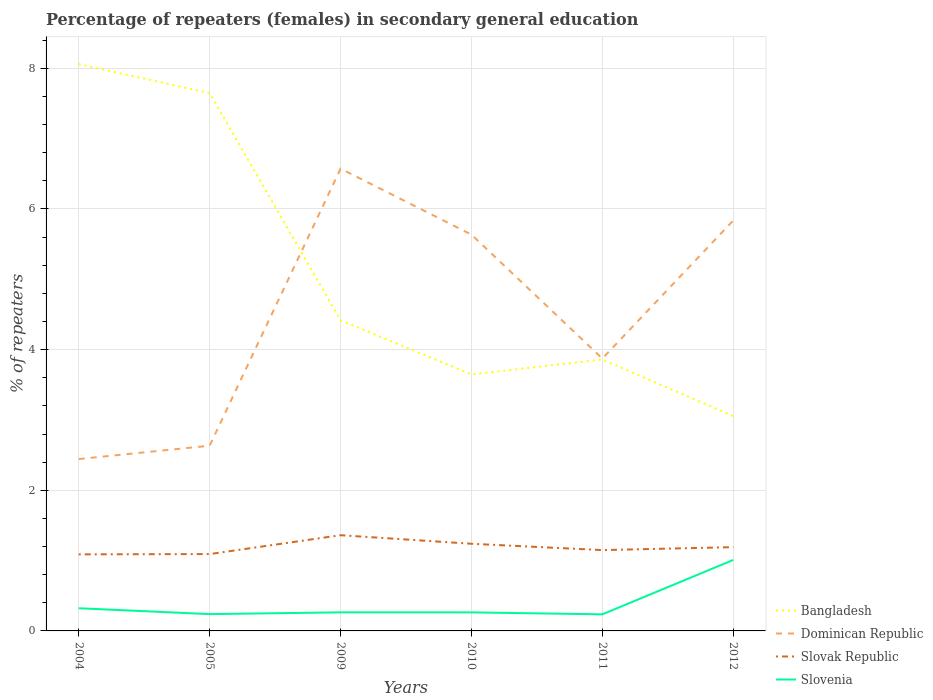How many different coloured lines are there?
Your answer should be compact. 4. Does the line corresponding to Slovenia intersect with the line corresponding to Bangladesh?
Offer a terse response. No. Is the number of lines equal to the number of legend labels?
Your answer should be compact. Yes. Across all years, what is the maximum percentage of female repeaters in Bangladesh?
Offer a terse response. 3.05. What is the total percentage of female repeaters in Slovak Republic in the graph?
Provide a succinct answer. 0.21. What is the difference between the highest and the second highest percentage of female repeaters in Bangladesh?
Offer a very short reply. 5.01. What is the difference between the highest and the lowest percentage of female repeaters in Slovenia?
Your response must be concise. 1. Is the percentage of female repeaters in Dominican Republic strictly greater than the percentage of female repeaters in Slovak Republic over the years?
Offer a terse response. No. How many years are there in the graph?
Offer a terse response. 6. Are the values on the major ticks of Y-axis written in scientific E-notation?
Ensure brevity in your answer.  No. Does the graph contain grids?
Your answer should be compact. Yes. Where does the legend appear in the graph?
Make the answer very short. Bottom right. How are the legend labels stacked?
Offer a very short reply. Vertical. What is the title of the graph?
Provide a short and direct response. Percentage of repeaters (females) in secondary general education. Does "Least developed countries" appear as one of the legend labels in the graph?
Your response must be concise. No. What is the label or title of the Y-axis?
Your answer should be very brief. % of repeaters. What is the % of repeaters in Bangladesh in 2004?
Your response must be concise. 8.06. What is the % of repeaters in Dominican Republic in 2004?
Provide a short and direct response. 2.44. What is the % of repeaters of Slovak Republic in 2004?
Provide a succinct answer. 1.09. What is the % of repeaters in Slovenia in 2004?
Your answer should be compact. 0.32. What is the % of repeaters of Bangladesh in 2005?
Keep it short and to the point. 7.65. What is the % of repeaters in Dominican Republic in 2005?
Keep it short and to the point. 2.63. What is the % of repeaters of Slovak Republic in 2005?
Keep it short and to the point. 1.09. What is the % of repeaters of Slovenia in 2005?
Give a very brief answer. 0.24. What is the % of repeaters in Bangladesh in 2009?
Your answer should be very brief. 4.42. What is the % of repeaters of Dominican Republic in 2009?
Make the answer very short. 6.57. What is the % of repeaters in Slovak Republic in 2009?
Your answer should be compact. 1.36. What is the % of repeaters in Slovenia in 2009?
Your response must be concise. 0.26. What is the % of repeaters of Bangladesh in 2010?
Make the answer very short. 3.65. What is the % of repeaters in Dominican Republic in 2010?
Ensure brevity in your answer.  5.64. What is the % of repeaters in Slovak Republic in 2010?
Offer a terse response. 1.24. What is the % of repeaters in Slovenia in 2010?
Your answer should be very brief. 0.26. What is the % of repeaters in Bangladesh in 2011?
Your response must be concise. 3.86. What is the % of repeaters of Dominican Republic in 2011?
Make the answer very short. 3.87. What is the % of repeaters of Slovak Republic in 2011?
Your response must be concise. 1.15. What is the % of repeaters in Slovenia in 2011?
Offer a terse response. 0.24. What is the % of repeaters in Bangladesh in 2012?
Provide a short and direct response. 3.05. What is the % of repeaters of Dominican Republic in 2012?
Offer a very short reply. 5.84. What is the % of repeaters of Slovak Republic in 2012?
Ensure brevity in your answer.  1.19. What is the % of repeaters of Slovenia in 2012?
Your answer should be compact. 1.01. Across all years, what is the maximum % of repeaters of Bangladesh?
Your answer should be very brief. 8.06. Across all years, what is the maximum % of repeaters of Dominican Republic?
Your answer should be compact. 6.57. Across all years, what is the maximum % of repeaters of Slovak Republic?
Keep it short and to the point. 1.36. Across all years, what is the maximum % of repeaters in Slovenia?
Provide a short and direct response. 1.01. Across all years, what is the minimum % of repeaters in Bangladesh?
Offer a terse response. 3.05. Across all years, what is the minimum % of repeaters of Dominican Republic?
Keep it short and to the point. 2.44. Across all years, what is the minimum % of repeaters in Slovak Republic?
Provide a succinct answer. 1.09. Across all years, what is the minimum % of repeaters of Slovenia?
Give a very brief answer. 0.24. What is the total % of repeaters of Bangladesh in the graph?
Keep it short and to the point. 30.69. What is the total % of repeaters of Dominican Republic in the graph?
Keep it short and to the point. 27. What is the total % of repeaters in Slovak Republic in the graph?
Your answer should be very brief. 7.12. What is the total % of repeaters of Slovenia in the graph?
Your answer should be compact. 2.33. What is the difference between the % of repeaters in Bangladesh in 2004 and that in 2005?
Offer a very short reply. 0.41. What is the difference between the % of repeaters of Dominican Republic in 2004 and that in 2005?
Your response must be concise. -0.19. What is the difference between the % of repeaters of Slovak Republic in 2004 and that in 2005?
Provide a short and direct response. -0. What is the difference between the % of repeaters in Slovenia in 2004 and that in 2005?
Give a very brief answer. 0.08. What is the difference between the % of repeaters of Bangladesh in 2004 and that in 2009?
Offer a very short reply. 3.64. What is the difference between the % of repeaters in Dominican Republic in 2004 and that in 2009?
Ensure brevity in your answer.  -4.13. What is the difference between the % of repeaters in Slovak Republic in 2004 and that in 2009?
Give a very brief answer. -0.27. What is the difference between the % of repeaters in Slovenia in 2004 and that in 2009?
Provide a succinct answer. 0.06. What is the difference between the % of repeaters in Bangladesh in 2004 and that in 2010?
Your answer should be compact. 4.41. What is the difference between the % of repeaters of Dominican Republic in 2004 and that in 2010?
Provide a short and direct response. -3.19. What is the difference between the % of repeaters of Slovak Republic in 2004 and that in 2010?
Give a very brief answer. -0.15. What is the difference between the % of repeaters in Slovenia in 2004 and that in 2010?
Keep it short and to the point. 0.06. What is the difference between the % of repeaters in Bangladesh in 2004 and that in 2011?
Your response must be concise. 4.2. What is the difference between the % of repeaters of Dominican Republic in 2004 and that in 2011?
Make the answer very short. -1.43. What is the difference between the % of repeaters in Slovak Republic in 2004 and that in 2011?
Your response must be concise. -0.06. What is the difference between the % of repeaters in Slovenia in 2004 and that in 2011?
Ensure brevity in your answer.  0.09. What is the difference between the % of repeaters in Bangladesh in 2004 and that in 2012?
Make the answer very short. 5.01. What is the difference between the % of repeaters in Dominican Republic in 2004 and that in 2012?
Provide a short and direct response. -3.39. What is the difference between the % of repeaters in Slovak Republic in 2004 and that in 2012?
Ensure brevity in your answer.  -0.1. What is the difference between the % of repeaters of Slovenia in 2004 and that in 2012?
Make the answer very short. -0.69. What is the difference between the % of repeaters of Bangladesh in 2005 and that in 2009?
Provide a short and direct response. 3.23. What is the difference between the % of repeaters in Dominican Republic in 2005 and that in 2009?
Your response must be concise. -3.94. What is the difference between the % of repeaters in Slovak Republic in 2005 and that in 2009?
Give a very brief answer. -0.27. What is the difference between the % of repeaters of Slovenia in 2005 and that in 2009?
Ensure brevity in your answer.  -0.03. What is the difference between the % of repeaters in Bangladesh in 2005 and that in 2010?
Give a very brief answer. 4. What is the difference between the % of repeaters in Dominican Republic in 2005 and that in 2010?
Offer a terse response. -3. What is the difference between the % of repeaters in Slovak Republic in 2005 and that in 2010?
Offer a very short reply. -0.15. What is the difference between the % of repeaters in Slovenia in 2005 and that in 2010?
Offer a terse response. -0.02. What is the difference between the % of repeaters in Bangladesh in 2005 and that in 2011?
Give a very brief answer. 3.79. What is the difference between the % of repeaters in Dominican Republic in 2005 and that in 2011?
Make the answer very short. -1.24. What is the difference between the % of repeaters in Slovak Republic in 2005 and that in 2011?
Offer a terse response. -0.06. What is the difference between the % of repeaters of Slovenia in 2005 and that in 2011?
Offer a very short reply. 0. What is the difference between the % of repeaters in Bangladesh in 2005 and that in 2012?
Give a very brief answer. 4.59. What is the difference between the % of repeaters of Dominican Republic in 2005 and that in 2012?
Offer a terse response. -3.2. What is the difference between the % of repeaters of Slovak Republic in 2005 and that in 2012?
Provide a succinct answer. -0.1. What is the difference between the % of repeaters of Slovenia in 2005 and that in 2012?
Give a very brief answer. -0.77. What is the difference between the % of repeaters of Bangladesh in 2009 and that in 2010?
Your response must be concise. 0.77. What is the difference between the % of repeaters in Dominican Republic in 2009 and that in 2010?
Provide a short and direct response. 0.94. What is the difference between the % of repeaters in Slovak Republic in 2009 and that in 2010?
Your answer should be compact. 0.12. What is the difference between the % of repeaters of Slovenia in 2009 and that in 2010?
Offer a terse response. 0. What is the difference between the % of repeaters in Bangladesh in 2009 and that in 2011?
Your answer should be compact. 0.56. What is the difference between the % of repeaters in Dominican Republic in 2009 and that in 2011?
Provide a succinct answer. 2.7. What is the difference between the % of repeaters in Slovak Republic in 2009 and that in 2011?
Keep it short and to the point. 0.21. What is the difference between the % of repeaters of Slovenia in 2009 and that in 2011?
Ensure brevity in your answer.  0.03. What is the difference between the % of repeaters of Bangladesh in 2009 and that in 2012?
Your answer should be very brief. 1.36. What is the difference between the % of repeaters of Dominican Republic in 2009 and that in 2012?
Keep it short and to the point. 0.74. What is the difference between the % of repeaters of Slovak Republic in 2009 and that in 2012?
Your answer should be compact. 0.17. What is the difference between the % of repeaters of Slovenia in 2009 and that in 2012?
Offer a very short reply. -0.74. What is the difference between the % of repeaters in Bangladesh in 2010 and that in 2011?
Ensure brevity in your answer.  -0.21. What is the difference between the % of repeaters of Dominican Republic in 2010 and that in 2011?
Provide a succinct answer. 1.76. What is the difference between the % of repeaters in Slovak Republic in 2010 and that in 2011?
Your answer should be compact. 0.09. What is the difference between the % of repeaters in Slovenia in 2010 and that in 2011?
Provide a succinct answer. 0.03. What is the difference between the % of repeaters of Bangladesh in 2010 and that in 2012?
Offer a terse response. 0.59. What is the difference between the % of repeaters of Dominican Republic in 2010 and that in 2012?
Your answer should be compact. -0.2. What is the difference between the % of repeaters of Slovak Republic in 2010 and that in 2012?
Provide a succinct answer. 0.05. What is the difference between the % of repeaters in Slovenia in 2010 and that in 2012?
Ensure brevity in your answer.  -0.75. What is the difference between the % of repeaters of Bangladesh in 2011 and that in 2012?
Make the answer very short. 0.81. What is the difference between the % of repeaters of Dominican Republic in 2011 and that in 2012?
Provide a short and direct response. -1.96. What is the difference between the % of repeaters in Slovak Republic in 2011 and that in 2012?
Provide a short and direct response. -0.04. What is the difference between the % of repeaters of Slovenia in 2011 and that in 2012?
Your answer should be compact. -0.77. What is the difference between the % of repeaters in Bangladesh in 2004 and the % of repeaters in Dominican Republic in 2005?
Provide a succinct answer. 5.43. What is the difference between the % of repeaters of Bangladesh in 2004 and the % of repeaters of Slovak Republic in 2005?
Your answer should be very brief. 6.97. What is the difference between the % of repeaters of Bangladesh in 2004 and the % of repeaters of Slovenia in 2005?
Your answer should be compact. 7.82. What is the difference between the % of repeaters of Dominican Republic in 2004 and the % of repeaters of Slovak Republic in 2005?
Make the answer very short. 1.35. What is the difference between the % of repeaters in Dominican Republic in 2004 and the % of repeaters in Slovenia in 2005?
Your answer should be compact. 2.2. What is the difference between the % of repeaters in Slovak Republic in 2004 and the % of repeaters in Slovenia in 2005?
Ensure brevity in your answer.  0.85. What is the difference between the % of repeaters of Bangladesh in 2004 and the % of repeaters of Dominican Republic in 2009?
Keep it short and to the point. 1.49. What is the difference between the % of repeaters in Bangladesh in 2004 and the % of repeaters in Slovak Republic in 2009?
Your answer should be compact. 6.7. What is the difference between the % of repeaters of Bangladesh in 2004 and the % of repeaters of Slovenia in 2009?
Your answer should be very brief. 7.8. What is the difference between the % of repeaters of Dominican Republic in 2004 and the % of repeaters of Slovak Republic in 2009?
Ensure brevity in your answer.  1.08. What is the difference between the % of repeaters in Dominican Republic in 2004 and the % of repeaters in Slovenia in 2009?
Offer a very short reply. 2.18. What is the difference between the % of repeaters of Slovak Republic in 2004 and the % of repeaters of Slovenia in 2009?
Make the answer very short. 0.82. What is the difference between the % of repeaters of Bangladesh in 2004 and the % of repeaters of Dominican Republic in 2010?
Provide a short and direct response. 2.42. What is the difference between the % of repeaters in Bangladesh in 2004 and the % of repeaters in Slovak Republic in 2010?
Offer a terse response. 6.82. What is the difference between the % of repeaters of Bangladesh in 2004 and the % of repeaters of Slovenia in 2010?
Ensure brevity in your answer.  7.8. What is the difference between the % of repeaters of Dominican Republic in 2004 and the % of repeaters of Slovak Republic in 2010?
Provide a succinct answer. 1.2. What is the difference between the % of repeaters of Dominican Republic in 2004 and the % of repeaters of Slovenia in 2010?
Ensure brevity in your answer.  2.18. What is the difference between the % of repeaters of Slovak Republic in 2004 and the % of repeaters of Slovenia in 2010?
Your answer should be very brief. 0.82. What is the difference between the % of repeaters in Bangladesh in 2004 and the % of repeaters in Dominican Republic in 2011?
Offer a terse response. 4.19. What is the difference between the % of repeaters in Bangladesh in 2004 and the % of repeaters in Slovak Republic in 2011?
Provide a succinct answer. 6.91. What is the difference between the % of repeaters of Bangladesh in 2004 and the % of repeaters of Slovenia in 2011?
Give a very brief answer. 7.82. What is the difference between the % of repeaters of Dominican Republic in 2004 and the % of repeaters of Slovak Republic in 2011?
Make the answer very short. 1.29. What is the difference between the % of repeaters in Dominican Republic in 2004 and the % of repeaters in Slovenia in 2011?
Offer a terse response. 2.21. What is the difference between the % of repeaters in Slovak Republic in 2004 and the % of repeaters in Slovenia in 2011?
Offer a very short reply. 0.85. What is the difference between the % of repeaters in Bangladesh in 2004 and the % of repeaters in Dominican Republic in 2012?
Ensure brevity in your answer.  2.22. What is the difference between the % of repeaters of Bangladesh in 2004 and the % of repeaters of Slovak Republic in 2012?
Your response must be concise. 6.87. What is the difference between the % of repeaters in Bangladesh in 2004 and the % of repeaters in Slovenia in 2012?
Keep it short and to the point. 7.05. What is the difference between the % of repeaters in Dominican Republic in 2004 and the % of repeaters in Slovak Republic in 2012?
Provide a short and direct response. 1.25. What is the difference between the % of repeaters in Dominican Republic in 2004 and the % of repeaters in Slovenia in 2012?
Offer a terse response. 1.43. What is the difference between the % of repeaters in Slovak Republic in 2004 and the % of repeaters in Slovenia in 2012?
Ensure brevity in your answer.  0.08. What is the difference between the % of repeaters in Bangladesh in 2005 and the % of repeaters in Dominican Republic in 2009?
Offer a very short reply. 1.07. What is the difference between the % of repeaters of Bangladesh in 2005 and the % of repeaters of Slovak Republic in 2009?
Offer a terse response. 6.29. What is the difference between the % of repeaters in Bangladesh in 2005 and the % of repeaters in Slovenia in 2009?
Your answer should be compact. 7.38. What is the difference between the % of repeaters in Dominican Republic in 2005 and the % of repeaters in Slovak Republic in 2009?
Offer a terse response. 1.27. What is the difference between the % of repeaters of Dominican Republic in 2005 and the % of repeaters of Slovenia in 2009?
Offer a terse response. 2.37. What is the difference between the % of repeaters in Slovak Republic in 2005 and the % of repeaters in Slovenia in 2009?
Provide a succinct answer. 0.83. What is the difference between the % of repeaters of Bangladesh in 2005 and the % of repeaters of Dominican Republic in 2010?
Provide a succinct answer. 2.01. What is the difference between the % of repeaters in Bangladesh in 2005 and the % of repeaters in Slovak Republic in 2010?
Provide a short and direct response. 6.41. What is the difference between the % of repeaters of Bangladesh in 2005 and the % of repeaters of Slovenia in 2010?
Your answer should be compact. 7.38. What is the difference between the % of repeaters of Dominican Republic in 2005 and the % of repeaters of Slovak Republic in 2010?
Offer a very short reply. 1.39. What is the difference between the % of repeaters in Dominican Republic in 2005 and the % of repeaters in Slovenia in 2010?
Your answer should be very brief. 2.37. What is the difference between the % of repeaters of Slovak Republic in 2005 and the % of repeaters of Slovenia in 2010?
Your response must be concise. 0.83. What is the difference between the % of repeaters of Bangladesh in 2005 and the % of repeaters of Dominican Republic in 2011?
Offer a terse response. 3.77. What is the difference between the % of repeaters in Bangladesh in 2005 and the % of repeaters in Slovak Republic in 2011?
Offer a very short reply. 6.5. What is the difference between the % of repeaters of Bangladesh in 2005 and the % of repeaters of Slovenia in 2011?
Provide a succinct answer. 7.41. What is the difference between the % of repeaters in Dominican Republic in 2005 and the % of repeaters in Slovak Republic in 2011?
Provide a succinct answer. 1.48. What is the difference between the % of repeaters in Dominican Republic in 2005 and the % of repeaters in Slovenia in 2011?
Offer a terse response. 2.4. What is the difference between the % of repeaters in Slovak Republic in 2005 and the % of repeaters in Slovenia in 2011?
Your answer should be compact. 0.86. What is the difference between the % of repeaters of Bangladesh in 2005 and the % of repeaters of Dominican Republic in 2012?
Your response must be concise. 1.81. What is the difference between the % of repeaters in Bangladesh in 2005 and the % of repeaters in Slovak Republic in 2012?
Ensure brevity in your answer.  6.46. What is the difference between the % of repeaters of Bangladesh in 2005 and the % of repeaters of Slovenia in 2012?
Give a very brief answer. 6.64. What is the difference between the % of repeaters in Dominican Republic in 2005 and the % of repeaters in Slovak Republic in 2012?
Keep it short and to the point. 1.44. What is the difference between the % of repeaters of Dominican Republic in 2005 and the % of repeaters of Slovenia in 2012?
Your answer should be very brief. 1.62. What is the difference between the % of repeaters in Slovak Republic in 2005 and the % of repeaters in Slovenia in 2012?
Offer a very short reply. 0.08. What is the difference between the % of repeaters of Bangladesh in 2009 and the % of repeaters of Dominican Republic in 2010?
Keep it short and to the point. -1.22. What is the difference between the % of repeaters in Bangladesh in 2009 and the % of repeaters in Slovak Republic in 2010?
Keep it short and to the point. 3.18. What is the difference between the % of repeaters of Bangladesh in 2009 and the % of repeaters of Slovenia in 2010?
Make the answer very short. 4.15. What is the difference between the % of repeaters in Dominican Republic in 2009 and the % of repeaters in Slovak Republic in 2010?
Offer a terse response. 5.33. What is the difference between the % of repeaters in Dominican Republic in 2009 and the % of repeaters in Slovenia in 2010?
Give a very brief answer. 6.31. What is the difference between the % of repeaters of Slovak Republic in 2009 and the % of repeaters of Slovenia in 2010?
Provide a short and direct response. 1.1. What is the difference between the % of repeaters of Bangladesh in 2009 and the % of repeaters of Dominican Republic in 2011?
Give a very brief answer. 0.54. What is the difference between the % of repeaters in Bangladesh in 2009 and the % of repeaters in Slovak Republic in 2011?
Offer a very short reply. 3.27. What is the difference between the % of repeaters in Bangladesh in 2009 and the % of repeaters in Slovenia in 2011?
Provide a short and direct response. 4.18. What is the difference between the % of repeaters of Dominican Republic in 2009 and the % of repeaters of Slovak Republic in 2011?
Provide a succinct answer. 5.42. What is the difference between the % of repeaters in Dominican Republic in 2009 and the % of repeaters in Slovenia in 2011?
Offer a very short reply. 6.34. What is the difference between the % of repeaters in Slovak Republic in 2009 and the % of repeaters in Slovenia in 2011?
Offer a terse response. 1.12. What is the difference between the % of repeaters in Bangladesh in 2009 and the % of repeaters in Dominican Republic in 2012?
Provide a short and direct response. -1.42. What is the difference between the % of repeaters in Bangladesh in 2009 and the % of repeaters in Slovak Republic in 2012?
Ensure brevity in your answer.  3.23. What is the difference between the % of repeaters in Bangladesh in 2009 and the % of repeaters in Slovenia in 2012?
Ensure brevity in your answer.  3.41. What is the difference between the % of repeaters in Dominican Republic in 2009 and the % of repeaters in Slovak Republic in 2012?
Offer a very short reply. 5.38. What is the difference between the % of repeaters in Dominican Republic in 2009 and the % of repeaters in Slovenia in 2012?
Provide a short and direct response. 5.56. What is the difference between the % of repeaters of Slovak Republic in 2009 and the % of repeaters of Slovenia in 2012?
Your response must be concise. 0.35. What is the difference between the % of repeaters in Bangladesh in 2010 and the % of repeaters in Dominican Republic in 2011?
Your answer should be very brief. -0.23. What is the difference between the % of repeaters in Bangladesh in 2010 and the % of repeaters in Slovak Republic in 2011?
Ensure brevity in your answer.  2.5. What is the difference between the % of repeaters of Bangladesh in 2010 and the % of repeaters of Slovenia in 2011?
Offer a very short reply. 3.41. What is the difference between the % of repeaters in Dominican Republic in 2010 and the % of repeaters in Slovak Republic in 2011?
Keep it short and to the point. 4.49. What is the difference between the % of repeaters in Dominican Republic in 2010 and the % of repeaters in Slovenia in 2011?
Your answer should be compact. 5.4. What is the difference between the % of repeaters in Slovak Republic in 2010 and the % of repeaters in Slovenia in 2011?
Make the answer very short. 1. What is the difference between the % of repeaters in Bangladesh in 2010 and the % of repeaters in Dominican Republic in 2012?
Provide a succinct answer. -2.19. What is the difference between the % of repeaters in Bangladesh in 2010 and the % of repeaters in Slovak Republic in 2012?
Provide a short and direct response. 2.46. What is the difference between the % of repeaters in Bangladesh in 2010 and the % of repeaters in Slovenia in 2012?
Your response must be concise. 2.64. What is the difference between the % of repeaters in Dominican Republic in 2010 and the % of repeaters in Slovak Republic in 2012?
Provide a succinct answer. 4.44. What is the difference between the % of repeaters of Dominican Republic in 2010 and the % of repeaters of Slovenia in 2012?
Provide a short and direct response. 4.63. What is the difference between the % of repeaters of Slovak Republic in 2010 and the % of repeaters of Slovenia in 2012?
Provide a short and direct response. 0.23. What is the difference between the % of repeaters in Bangladesh in 2011 and the % of repeaters in Dominican Republic in 2012?
Offer a very short reply. -1.98. What is the difference between the % of repeaters in Bangladesh in 2011 and the % of repeaters in Slovak Republic in 2012?
Your answer should be very brief. 2.67. What is the difference between the % of repeaters in Bangladesh in 2011 and the % of repeaters in Slovenia in 2012?
Your answer should be very brief. 2.85. What is the difference between the % of repeaters in Dominican Republic in 2011 and the % of repeaters in Slovak Republic in 2012?
Keep it short and to the point. 2.68. What is the difference between the % of repeaters of Dominican Republic in 2011 and the % of repeaters of Slovenia in 2012?
Your answer should be very brief. 2.86. What is the difference between the % of repeaters in Slovak Republic in 2011 and the % of repeaters in Slovenia in 2012?
Your answer should be compact. 0.14. What is the average % of repeaters of Bangladesh per year?
Ensure brevity in your answer.  5.11. What is the average % of repeaters in Dominican Republic per year?
Your answer should be compact. 4.5. What is the average % of repeaters in Slovak Republic per year?
Keep it short and to the point. 1.19. What is the average % of repeaters of Slovenia per year?
Provide a short and direct response. 0.39. In the year 2004, what is the difference between the % of repeaters of Bangladesh and % of repeaters of Dominican Republic?
Offer a very short reply. 5.62. In the year 2004, what is the difference between the % of repeaters in Bangladesh and % of repeaters in Slovak Republic?
Make the answer very short. 6.97. In the year 2004, what is the difference between the % of repeaters in Bangladesh and % of repeaters in Slovenia?
Your response must be concise. 7.74. In the year 2004, what is the difference between the % of repeaters of Dominican Republic and % of repeaters of Slovak Republic?
Give a very brief answer. 1.36. In the year 2004, what is the difference between the % of repeaters of Dominican Republic and % of repeaters of Slovenia?
Ensure brevity in your answer.  2.12. In the year 2004, what is the difference between the % of repeaters in Slovak Republic and % of repeaters in Slovenia?
Your answer should be very brief. 0.77. In the year 2005, what is the difference between the % of repeaters of Bangladesh and % of repeaters of Dominican Republic?
Give a very brief answer. 5.01. In the year 2005, what is the difference between the % of repeaters in Bangladesh and % of repeaters in Slovak Republic?
Keep it short and to the point. 6.55. In the year 2005, what is the difference between the % of repeaters in Bangladesh and % of repeaters in Slovenia?
Your response must be concise. 7.41. In the year 2005, what is the difference between the % of repeaters of Dominican Republic and % of repeaters of Slovak Republic?
Make the answer very short. 1.54. In the year 2005, what is the difference between the % of repeaters of Dominican Republic and % of repeaters of Slovenia?
Provide a succinct answer. 2.39. In the year 2005, what is the difference between the % of repeaters in Slovak Republic and % of repeaters in Slovenia?
Keep it short and to the point. 0.85. In the year 2009, what is the difference between the % of repeaters of Bangladesh and % of repeaters of Dominican Republic?
Your response must be concise. -2.16. In the year 2009, what is the difference between the % of repeaters of Bangladesh and % of repeaters of Slovak Republic?
Provide a short and direct response. 3.06. In the year 2009, what is the difference between the % of repeaters of Bangladesh and % of repeaters of Slovenia?
Provide a short and direct response. 4.15. In the year 2009, what is the difference between the % of repeaters of Dominican Republic and % of repeaters of Slovak Republic?
Your response must be concise. 5.21. In the year 2009, what is the difference between the % of repeaters of Dominican Republic and % of repeaters of Slovenia?
Your response must be concise. 6.31. In the year 2009, what is the difference between the % of repeaters in Slovak Republic and % of repeaters in Slovenia?
Keep it short and to the point. 1.1. In the year 2010, what is the difference between the % of repeaters in Bangladesh and % of repeaters in Dominican Republic?
Make the answer very short. -1.99. In the year 2010, what is the difference between the % of repeaters of Bangladesh and % of repeaters of Slovak Republic?
Your answer should be compact. 2.41. In the year 2010, what is the difference between the % of repeaters of Bangladesh and % of repeaters of Slovenia?
Provide a succinct answer. 3.38. In the year 2010, what is the difference between the % of repeaters in Dominican Republic and % of repeaters in Slovak Republic?
Give a very brief answer. 4.4. In the year 2010, what is the difference between the % of repeaters of Dominican Republic and % of repeaters of Slovenia?
Your answer should be very brief. 5.37. In the year 2010, what is the difference between the % of repeaters in Slovak Republic and % of repeaters in Slovenia?
Offer a very short reply. 0.98. In the year 2011, what is the difference between the % of repeaters in Bangladesh and % of repeaters in Dominican Republic?
Provide a succinct answer. -0.01. In the year 2011, what is the difference between the % of repeaters in Bangladesh and % of repeaters in Slovak Republic?
Your answer should be compact. 2.71. In the year 2011, what is the difference between the % of repeaters in Bangladesh and % of repeaters in Slovenia?
Ensure brevity in your answer.  3.62. In the year 2011, what is the difference between the % of repeaters in Dominican Republic and % of repeaters in Slovak Republic?
Make the answer very short. 2.72. In the year 2011, what is the difference between the % of repeaters of Dominican Republic and % of repeaters of Slovenia?
Your response must be concise. 3.64. In the year 2011, what is the difference between the % of repeaters in Slovak Republic and % of repeaters in Slovenia?
Your answer should be very brief. 0.91. In the year 2012, what is the difference between the % of repeaters in Bangladesh and % of repeaters in Dominican Republic?
Your answer should be very brief. -2.78. In the year 2012, what is the difference between the % of repeaters in Bangladesh and % of repeaters in Slovak Republic?
Ensure brevity in your answer.  1.86. In the year 2012, what is the difference between the % of repeaters in Bangladesh and % of repeaters in Slovenia?
Your answer should be very brief. 2.04. In the year 2012, what is the difference between the % of repeaters in Dominican Republic and % of repeaters in Slovak Republic?
Your response must be concise. 4.64. In the year 2012, what is the difference between the % of repeaters in Dominican Republic and % of repeaters in Slovenia?
Your answer should be compact. 4.83. In the year 2012, what is the difference between the % of repeaters of Slovak Republic and % of repeaters of Slovenia?
Your response must be concise. 0.18. What is the ratio of the % of repeaters in Bangladesh in 2004 to that in 2005?
Provide a short and direct response. 1.05. What is the ratio of the % of repeaters in Dominican Republic in 2004 to that in 2005?
Offer a terse response. 0.93. What is the ratio of the % of repeaters in Slovenia in 2004 to that in 2005?
Your answer should be compact. 1.35. What is the ratio of the % of repeaters of Bangladesh in 2004 to that in 2009?
Make the answer very short. 1.82. What is the ratio of the % of repeaters of Dominican Republic in 2004 to that in 2009?
Offer a very short reply. 0.37. What is the ratio of the % of repeaters in Slovenia in 2004 to that in 2009?
Make the answer very short. 1.22. What is the ratio of the % of repeaters of Bangladesh in 2004 to that in 2010?
Your answer should be very brief. 2.21. What is the ratio of the % of repeaters of Dominican Republic in 2004 to that in 2010?
Your answer should be very brief. 0.43. What is the ratio of the % of repeaters in Slovak Republic in 2004 to that in 2010?
Offer a terse response. 0.88. What is the ratio of the % of repeaters of Slovenia in 2004 to that in 2010?
Give a very brief answer. 1.22. What is the ratio of the % of repeaters of Bangladesh in 2004 to that in 2011?
Make the answer very short. 2.09. What is the ratio of the % of repeaters in Dominican Republic in 2004 to that in 2011?
Provide a short and direct response. 0.63. What is the ratio of the % of repeaters in Slovak Republic in 2004 to that in 2011?
Ensure brevity in your answer.  0.95. What is the ratio of the % of repeaters of Slovenia in 2004 to that in 2011?
Ensure brevity in your answer.  1.37. What is the ratio of the % of repeaters of Bangladesh in 2004 to that in 2012?
Ensure brevity in your answer.  2.64. What is the ratio of the % of repeaters of Dominican Republic in 2004 to that in 2012?
Provide a succinct answer. 0.42. What is the ratio of the % of repeaters of Slovak Republic in 2004 to that in 2012?
Provide a short and direct response. 0.91. What is the ratio of the % of repeaters in Slovenia in 2004 to that in 2012?
Your answer should be very brief. 0.32. What is the ratio of the % of repeaters in Bangladesh in 2005 to that in 2009?
Keep it short and to the point. 1.73. What is the ratio of the % of repeaters of Dominican Republic in 2005 to that in 2009?
Your response must be concise. 0.4. What is the ratio of the % of repeaters in Slovak Republic in 2005 to that in 2009?
Provide a short and direct response. 0.8. What is the ratio of the % of repeaters of Slovenia in 2005 to that in 2009?
Offer a very short reply. 0.9. What is the ratio of the % of repeaters in Bangladesh in 2005 to that in 2010?
Make the answer very short. 2.1. What is the ratio of the % of repeaters in Dominican Republic in 2005 to that in 2010?
Your response must be concise. 0.47. What is the ratio of the % of repeaters in Slovak Republic in 2005 to that in 2010?
Your answer should be very brief. 0.88. What is the ratio of the % of repeaters in Slovenia in 2005 to that in 2010?
Provide a short and direct response. 0.91. What is the ratio of the % of repeaters of Bangladesh in 2005 to that in 2011?
Offer a terse response. 1.98. What is the ratio of the % of repeaters of Dominican Republic in 2005 to that in 2011?
Ensure brevity in your answer.  0.68. What is the ratio of the % of repeaters in Slovak Republic in 2005 to that in 2011?
Offer a terse response. 0.95. What is the ratio of the % of repeaters of Slovenia in 2005 to that in 2011?
Your response must be concise. 1.01. What is the ratio of the % of repeaters of Bangladesh in 2005 to that in 2012?
Offer a terse response. 2.5. What is the ratio of the % of repeaters of Dominican Republic in 2005 to that in 2012?
Keep it short and to the point. 0.45. What is the ratio of the % of repeaters of Slovak Republic in 2005 to that in 2012?
Offer a very short reply. 0.92. What is the ratio of the % of repeaters in Slovenia in 2005 to that in 2012?
Provide a succinct answer. 0.24. What is the ratio of the % of repeaters of Bangladesh in 2009 to that in 2010?
Your answer should be very brief. 1.21. What is the ratio of the % of repeaters of Dominican Republic in 2009 to that in 2010?
Give a very brief answer. 1.17. What is the ratio of the % of repeaters of Slovak Republic in 2009 to that in 2010?
Ensure brevity in your answer.  1.1. What is the ratio of the % of repeaters of Slovenia in 2009 to that in 2010?
Offer a terse response. 1. What is the ratio of the % of repeaters of Bangladesh in 2009 to that in 2011?
Provide a short and direct response. 1.14. What is the ratio of the % of repeaters of Dominican Republic in 2009 to that in 2011?
Keep it short and to the point. 1.7. What is the ratio of the % of repeaters in Slovak Republic in 2009 to that in 2011?
Your response must be concise. 1.18. What is the ratio of the % of repeaters in Slovenia in 2009 to that in 2011?
Give a very brief answer. 1.12. What is the ratio of the % of repeaters of Bangladesh in 2009 to that in 2012?
Ensure brevity in your answer.  1.45. What is the ratio of the % of repeaters in Dominican Republic in 2009 to that in 2012?
Your answer should be compact. 1.13. What is the ratio of the % of repeaters of Slovak Republic in 2009 to that in 2012?
Keep it short and to the point. 1.14. What is the ratio of the % of repeaters in Slovenia in 2009 to that in 2012?
Offer a terse response. 0.26. What is the ratio of the % of repeaters in Bangladesh in 2010 to that in 2011?
Offer a very short reply. 0.94. What is the ratio of the % of repeaters of Dominican Republic in 2010 to that in 2011?
Your answer should be compact. 1.46. What is the ratio of the % of repeaters in Slovak Republic in 2010 to that in 2011?
Make the answer very short. 1.08. What is the ratio of the % of repeaters in Slovenia in 2010 to that in 2011?
Offer a very short reply. 1.12. What is the ratio of the % of repeaters of Bangladesh in 2010 to that in 2012?
Your response must be concise. 1.19. What is the ratio of the % of repeaters of Dominican Republic in 2010 to that in 2012?
Give a very brief answer. 0.97. What is the ratio of the % of repeaters of Slovak Republic in 2010 to that in 2012?
Make the answer very short. 1.04. What is the ratio of the % of repeaters in Slovenia in 2010 to that in 2012?
Your response must be concise. 0.26. What is the ratio of the % of repeaters in Bangladesh in 2011 to that in 2012?
Your answer should be compact. 1.26. What is the ratio of the % of repeaters of Dominican Republic in 2011 to that in 2012?
Provide a short and direct response. 0.66. What is the ratio of the % of repeaters in Slovak Republic in 2011 to that in 2012?
Offer a terse response. 0.96. What is the ratio of the % of repeaters of Slovenia in 2011 to that in 2012?
Offer a terse response. 0.23. What is the difference between the highest and the second highest % of repeaters in Bangladesh?
Make the answer very short. 0.41. What is the difference between the highest and the second highest % of repeaters in Dominican Republic?
Your answer should be compact. 0.74. What is the difference between the highest and the second highest % of repeaters of Slovak Republic?
Your answer should be very brief. 0.12. What is the difference between the highest and the second highest % of repeaters of Slovenia?
Your response must be concise. 0.69. What is the difference between the highest and the lowest % of repeaters in Bangladesh?
Offer a very short reply. 5.01. What is the difference between the highest and the lowest % of repeaters in Dominican Republic?
Provide a succinct answer. 4.13. What is the difference between the highest and the lowest % of repeaters of Slovak Republic?
Keep it short and to the point. 0.27. What is the difference between the highest and the lowest % of repeaters of Slovenia?
Keep it short and to the point. 0.77. 